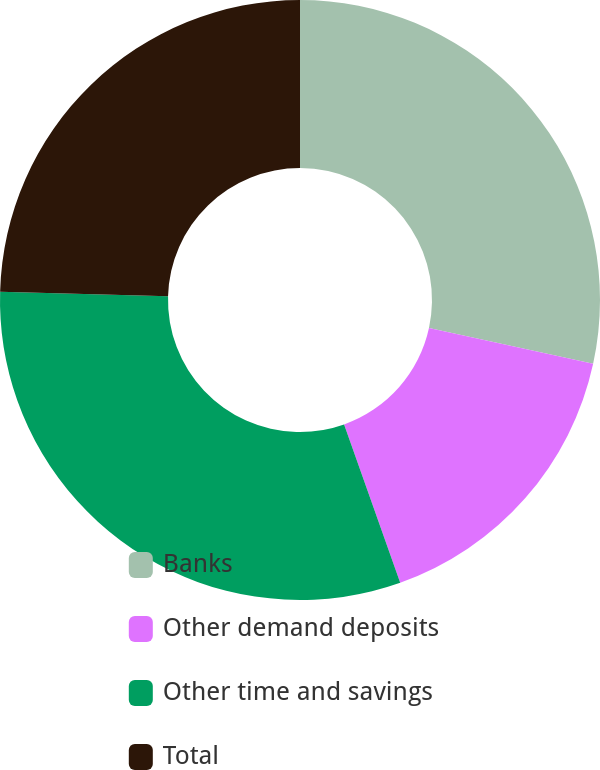<chart> <loc_0><loc_0><loc_500><loc_500><pie_chart><fcel>Banks<fcel>Other demand deposits<fcel>Other time and savings<fcel>Total<nl><fcel>28.41%<fcel>16.17%<fcel>30.86%<fcel>24.56%<nl></chart> 